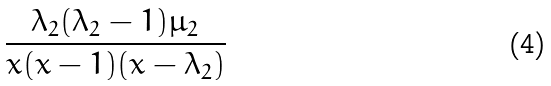Convert formula to latex. <formula><loc_0><loc_0><loc_500><loc_500>\frac { \lambda _ { 2 } ( \lambda _ { 2 } - 1 ) \mu _ { 2 } } { x ( x - 1 ) ( x - \lambda _ { 2 } ) }</formula> 